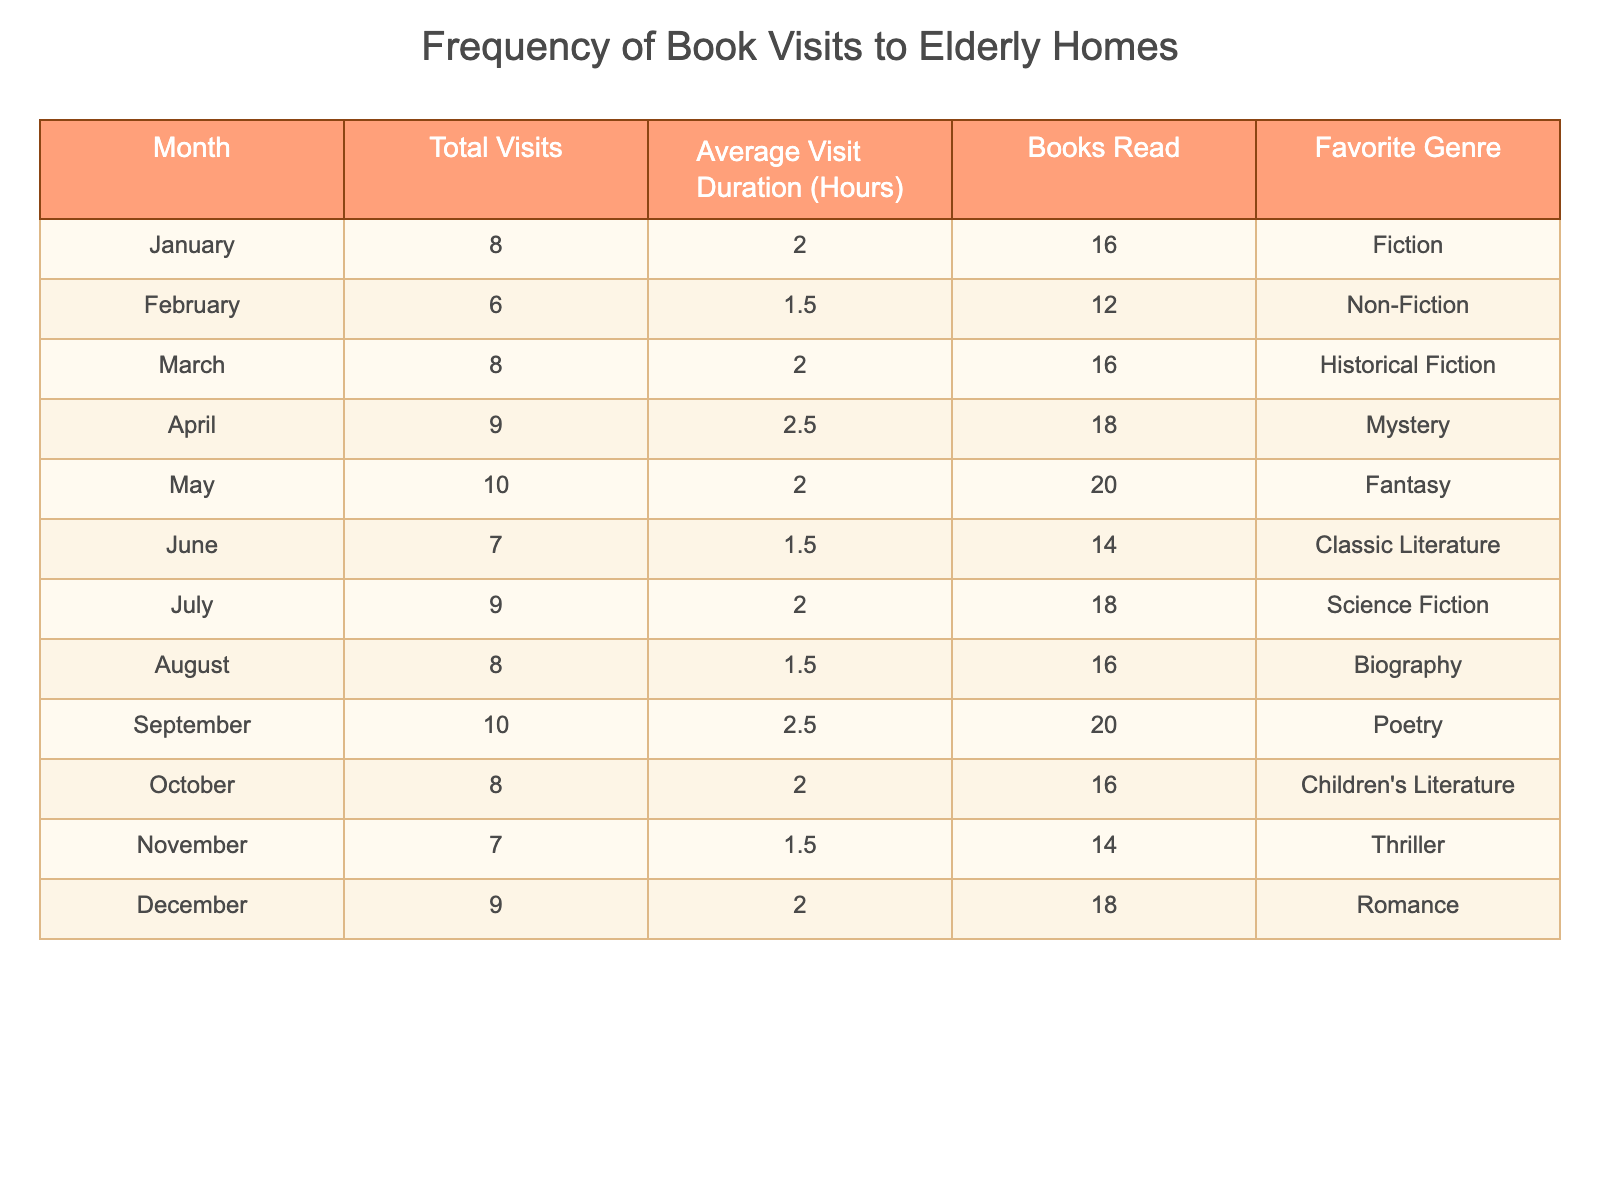What is the total number of visits made in December? The table indicates that the total visits for December is listed in the respective row under "Total Visits". That value is 9.
Answer: 9 Which month had the highest average visit duration? Looking at the "Average Visit Duration (Hours)" column, the highest value is 2.5 hours, found in both April and September. Since both months have the same highest duration, they are tied for this answer.
Answer: April and September How many books were read in May? The row for May shows the value in the "Books Read" column, which is 20.
Answer: 20 What is the total number of visits from January to March? To find the total visits in these months, I add the "Total Visits" for January (8) + February (6) + March (8), which equals 22.
Answer: 22 Is the favorite genre of the visits in June Classic Literature? Referring to the "Favorite Genre" column for June, it is listed as Classic Literature, so the answer is true.
Answer: Yes Which month involves more visits, July or August? By comparing the "Total Visits" for July (9) and August (8), it's clear that July involves more visits since 9 is greater than 8.
Answer: July Calculate the average number of books read per visit in November. The table shows that 7 visits were made in November, and a total of 14 books were read. To find the average: 14 books / 7 visits = 2 books per visit.
Answer: 2 How many fewer visits were made in February compared to April? February reports 6 visits, while April has 9 visits. By subtracting these values: 9 - 6 = 3, so there were 3 fewer visits in February than in April.
Answer: 3 In which month was the romance genre the favorite? The "Favorite Genre" column shows that Romance is the favorite in December.
Answer: December 